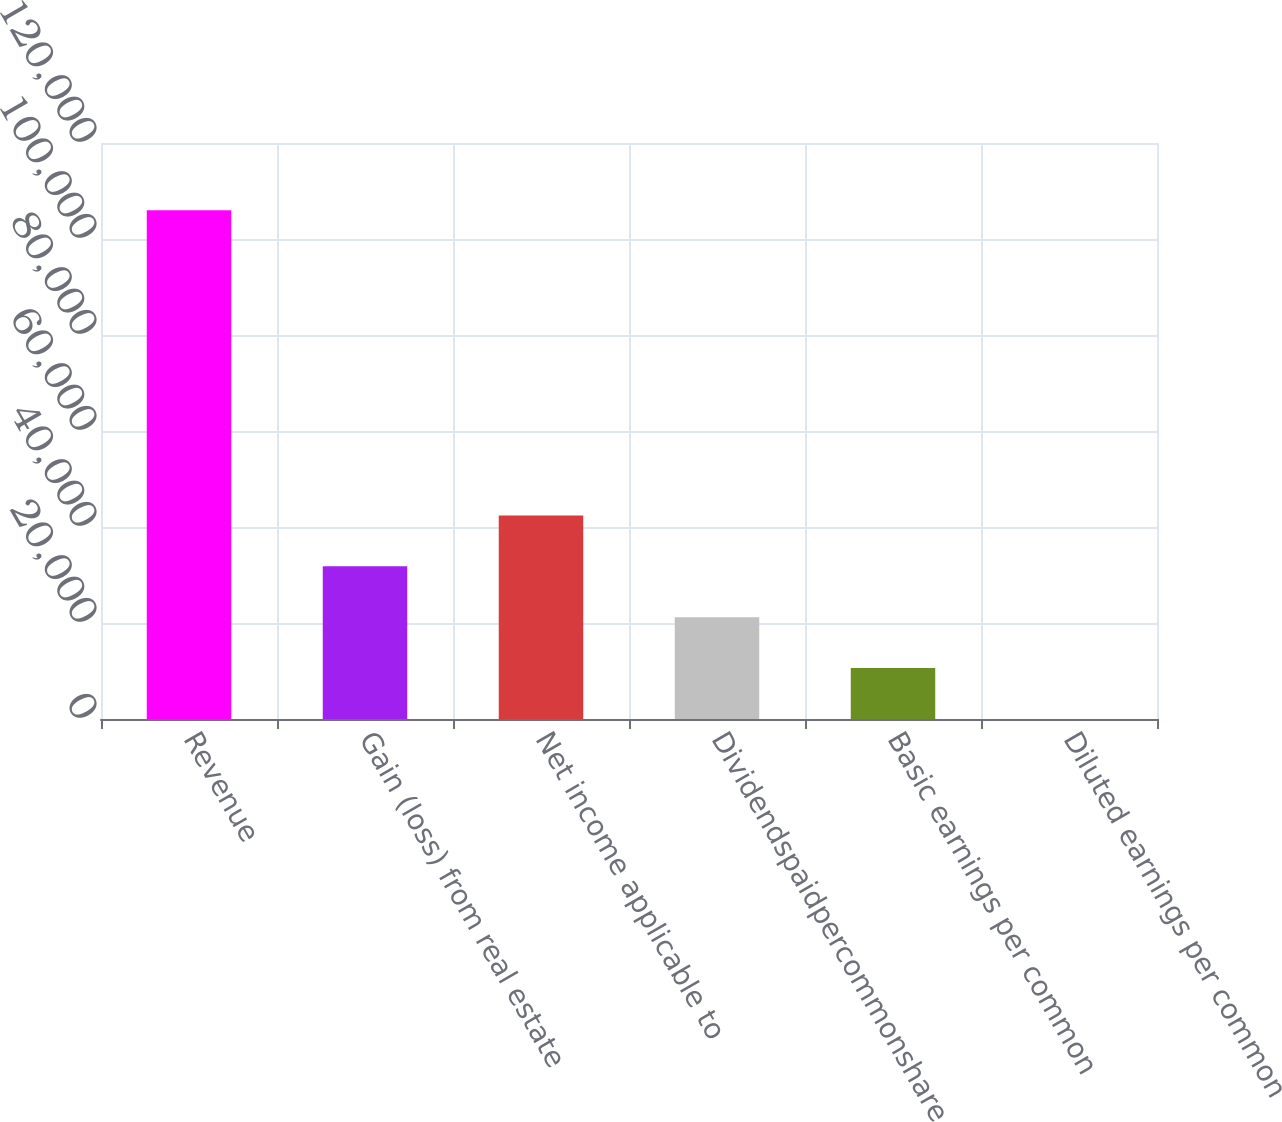Convert chart to OTSL. <chart><loc_0><loc_0><loc_500><loc_500><bar_chart><fcel>Revenue<fcel>Gain (loss) from real estate<fcel>Net income applicable to<fcel>Dividendspaidpercommonshare<fcel>Basic earnings per common<fcel>Diluted earnings per common<nl><fcel>106001<fcel>31800.5<fcel>42400.6<fcel>21200.4<fcel>10600.3<fcel>0.27<nl></chart> 